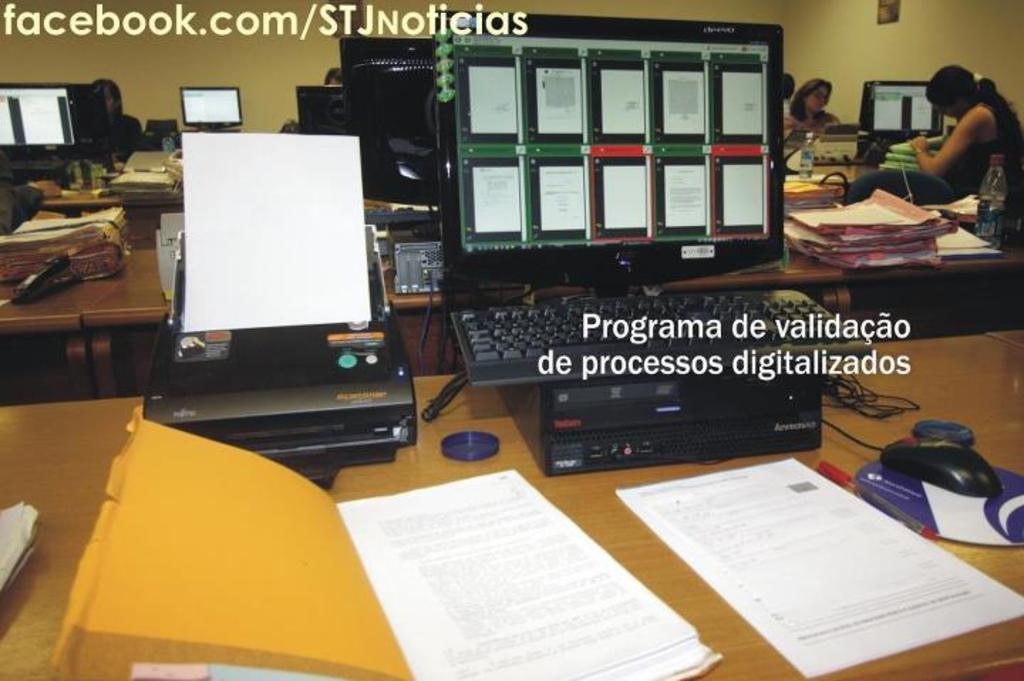How would you summarize this image in a sentence or two? In this picture we can see tables here, there is a monitor, a keyboard, a mouse, a printer, some papers and a file present on this table, in the background there are two persons, we can see a wall here, there is some text here. 